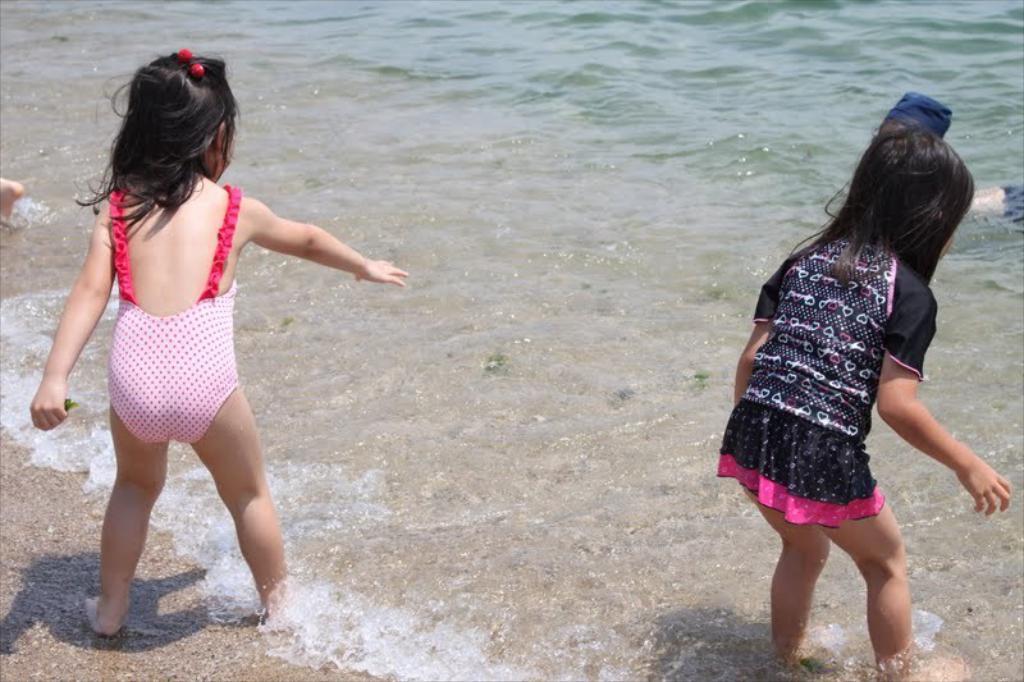Describe this image in one or two sentences. In this image I can see two girls are standing in the water. 